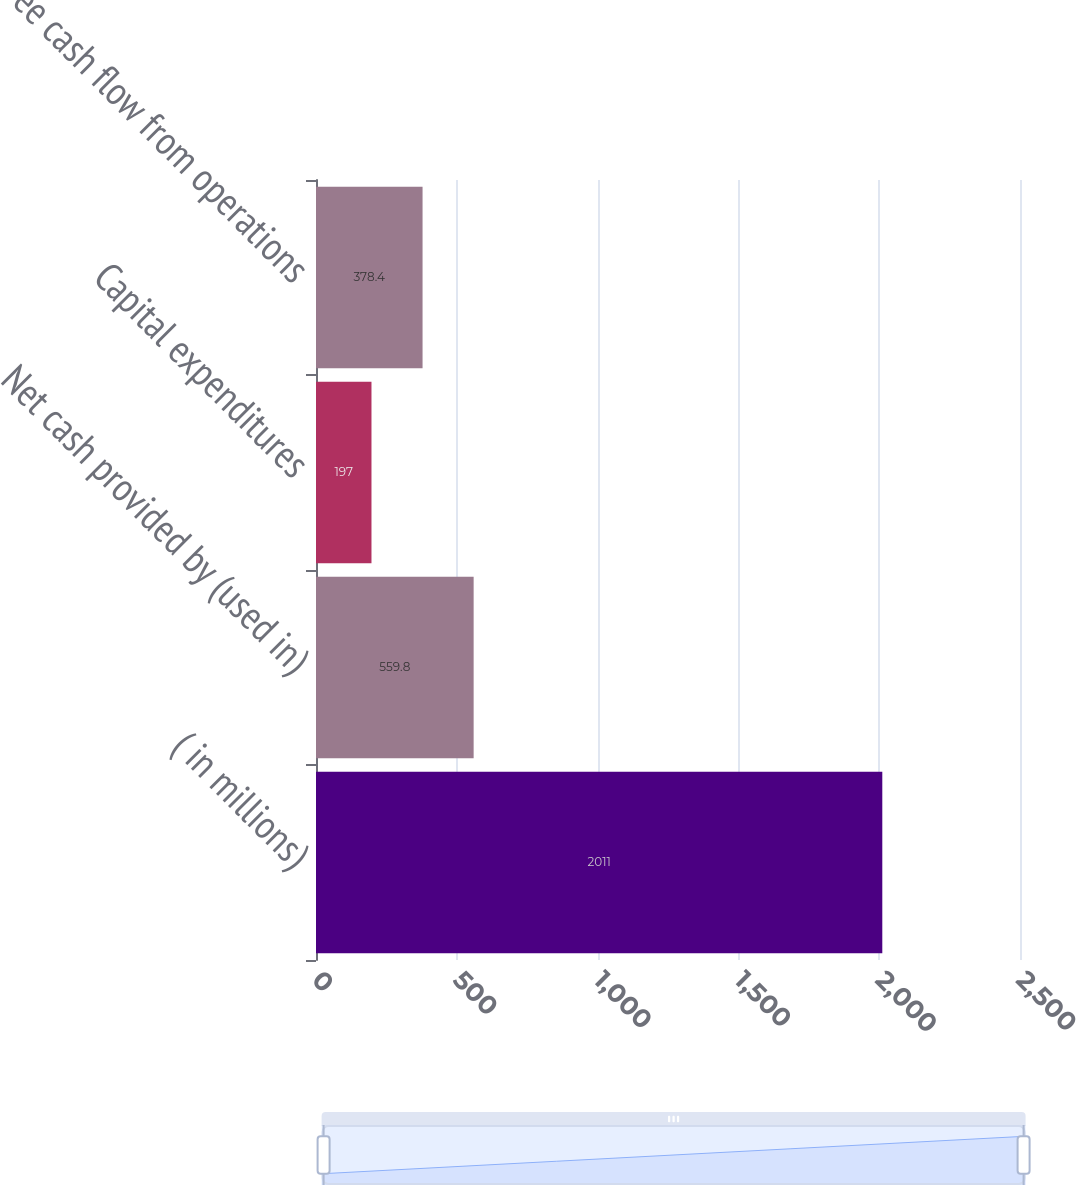Convert chart. <chart><loc_0><loc_0><loc_500><loc_500><bar_chart><fcel>( in millions)<fcel>Net cash provided by (used in)<fcel>Capital expenditures<fcel>Free cash flow from operations<nl><fcel>2011<fcel>559.8<fcel>197<fcel>378.4<nl></chart> 